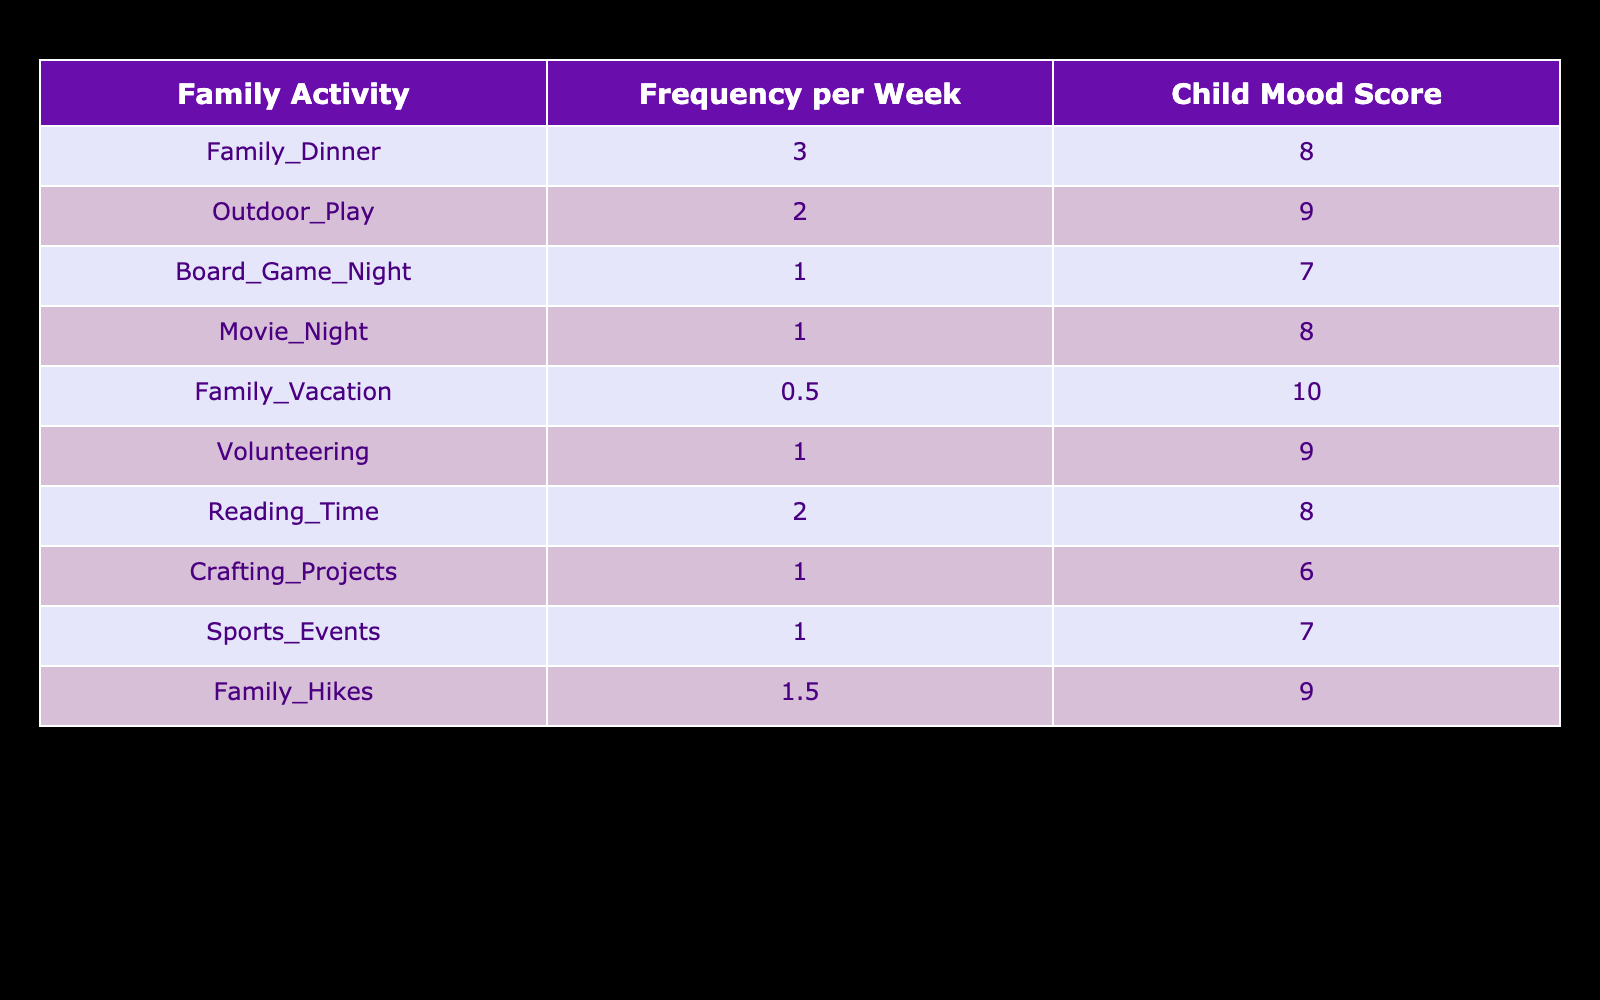What is the child mood score after Family Dinner? The table shows that the child mood score after Family Dinner is 8.
Answer: 8 How often does the family engage in Outdoor Play per week? The table indicates that the frequency of Outdoor Play per week is 2.
Answer: 2 Which activity has the highest child mood score and what is that score? By checking the table, Family Vacation has the highest child mood score of 10.
Answer: 10 Is the child mood score after Board Game Night higher than that after Crafting Projects? The table shows a mood score of 7 for Board Game Night and a score of 6 for Crafting Projects. Since 7 is greater than 6, the answer is yes.
Answer: Yes What is the average child mood score for all the activities listed? To find the average mood score, we first sum all the scores: 8 + 9 + 7 + 8 + 10 + 9 + 8 + 6 + 7 + 9 = 81. There are 10 activities, so we divide: 81 / 10 = 8.1.
Answer: 8.1 What is the total frequency of family activities that score 8 or above in child mood? The activities with scores of 8 or above are Family Dinner (3), Outdoor Play (2), Family Vacation (0.5), Reading Time (2), and Family Hikes (1.5). The total frequency is 3 + 2 + 0.5 + 2 + 1.5 = 9.
Answer: 9 How many family activities have a frequency of 1 or less per week? The activities that fall into this category are Board Game Night (1), Movie Night (1), and Family Vacation (0.5), totaling three activities.
Answer: 3 Is the frequency of Family Hikes greater than the frequency of Volunteering? Family Hikes occur 1.5 times per week and Volunteering occurs 1 time per week. Since 1.5 is greater than 1, the answer is yes.
Answer: Yes Which family activity has a mood score lower than a frequency of 1? Crafting Projects has a frequency of 1 and a mood score of 6. All others with a frequency lower than 1 (only Family Vacation at 0.5) has a mood score of 10, which is not lower. Therefore, there is no such activity.
Answer: None 